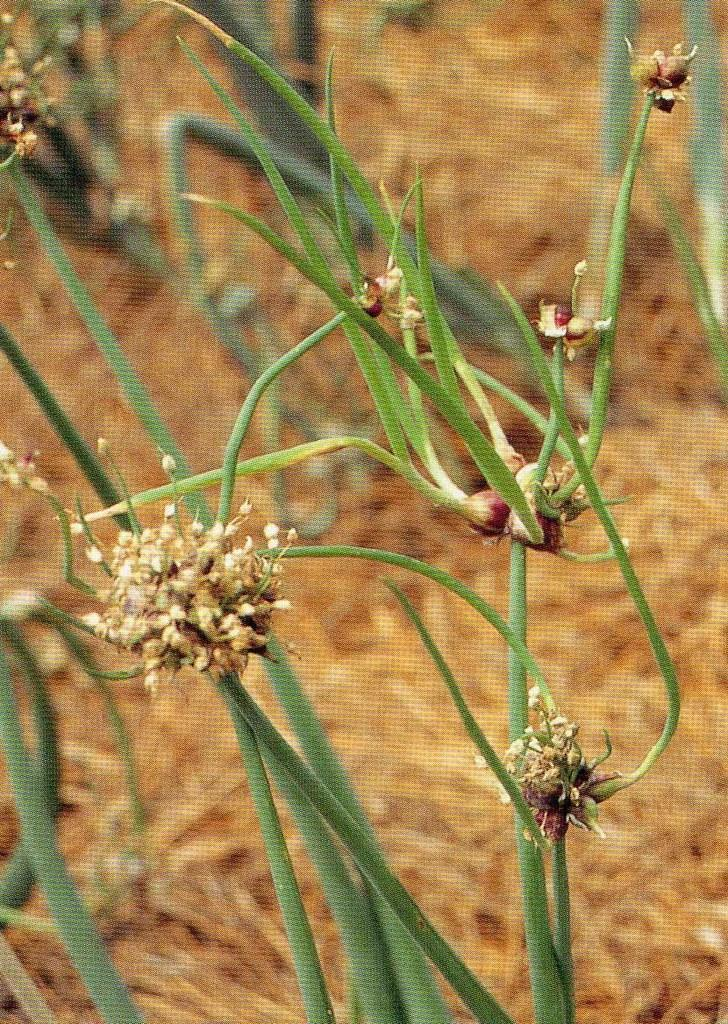What type of living organisms can be seen in the image? Plants can be seen in the image. What is the condition of the grass in the background of the image? The grass in the background of the image is dry. What type of glass can be seen rolling across the dry grass in the image? There is no glass or rolling object present in the image. 